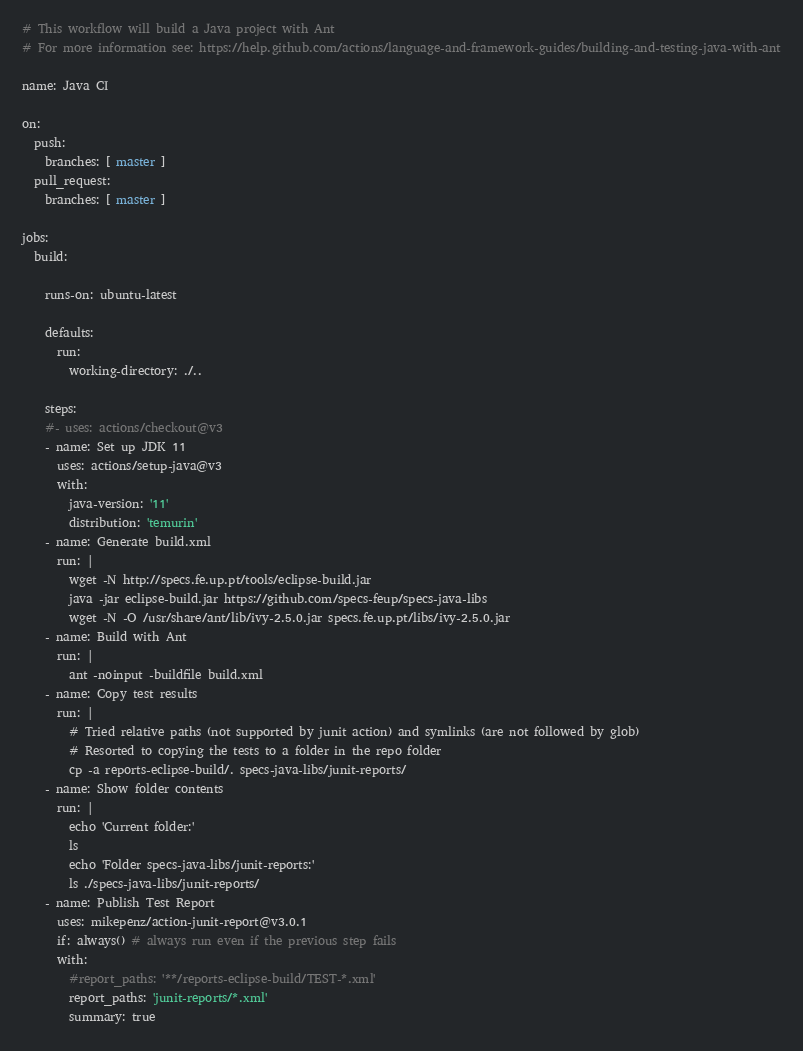Convert code to text. <code><loc_0><loc_0><loc_500><loc_500><_YAML_># This workflow will build a Java project with Ant
# For more information see: https://help.github.com/actions/language-and-framework-guides/building-and-testing-java-with-ant

name: Java CI

on:
  push:
    branches: [ master ]
  pull_request:
    branches: [ master ]

jobs:
  build:

    runs-on: ubuntu-latest

    defaults:
      run:
        working-directory: ./..

    steps:
    #- uses: actions/checkout@v3
    - name: Set up JDK 11
      uses: actions/setup-java@v3
      with:
        java-version: '11'
        distribution: 'temurin'
    - name: Generate build.xml
      run: | 
        wget -N http://specs.fe.up.pt/tools/eclipse-build.jar
        java -jar eclipse-build.jar https://github.com/specs-feup/specs-java-libs
        wget -N -O /usr/share/ant/lib/ivy-2.5.0.jar specs.fe.up.pt/libs/ivy-2.5.0.jar
    - name: Build with Ant
      run: |
        ant -noinput -buildfile build.xml        
    - name: Copy test results        
      run: |
        # Tried relative paths (not supported by junit action) and symlinks (are not followed by glob)
        # Resorted to copying the tests to a folder in the repo folder
        cp -a reports-eclipse-build/. specs-java-libs/junit-reports/        
    - name: Show folder contents
      run: |
        echo 'Current folder:'
        ls
        echo 'Folder specs-java-libs/junit-reports:'
        ls ./specs-java-libs/junit-reports/
    - name: Publish Test Report 
      uses: mikepenz/action-junit-report@v3.0.1
      if: always() # always run even if the previous step fails
      with:
        #report_paths: '**/reports-eclipse-build/TEST-*.xml'
        report_paths: 'junit-reports/*.xml'      
        summary: true
</code> 